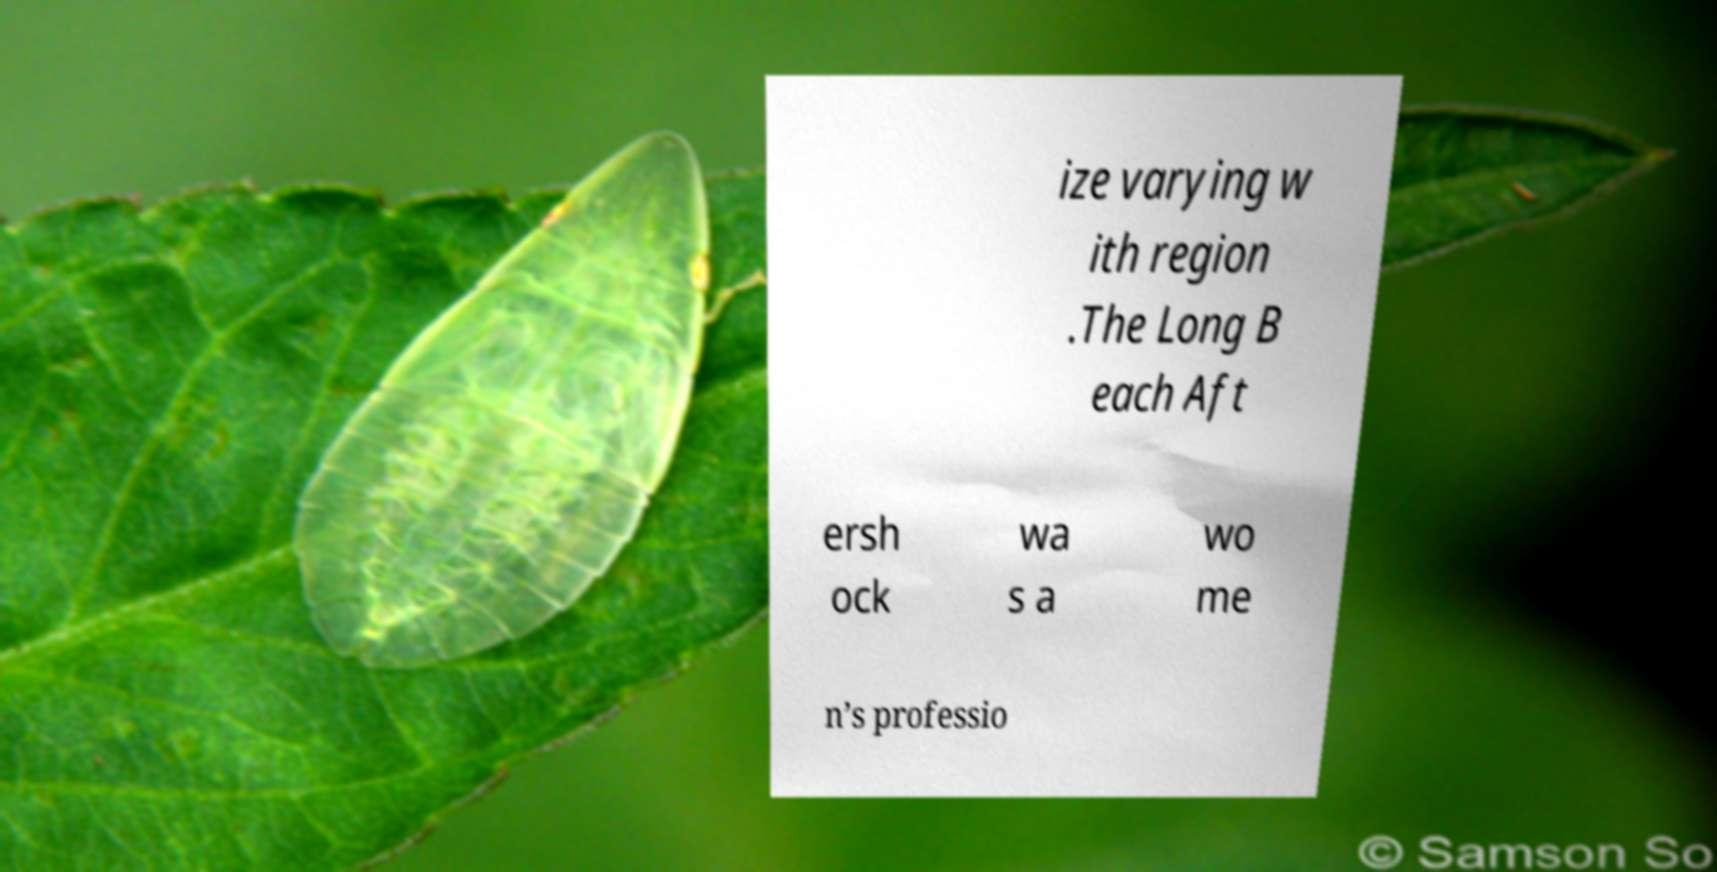There's text embedded in this image that I need extracted. Can you transcribe it verbatim? ize varying w ith region .The Long B each Aft ersh ock wa s a wo me n’s professio 